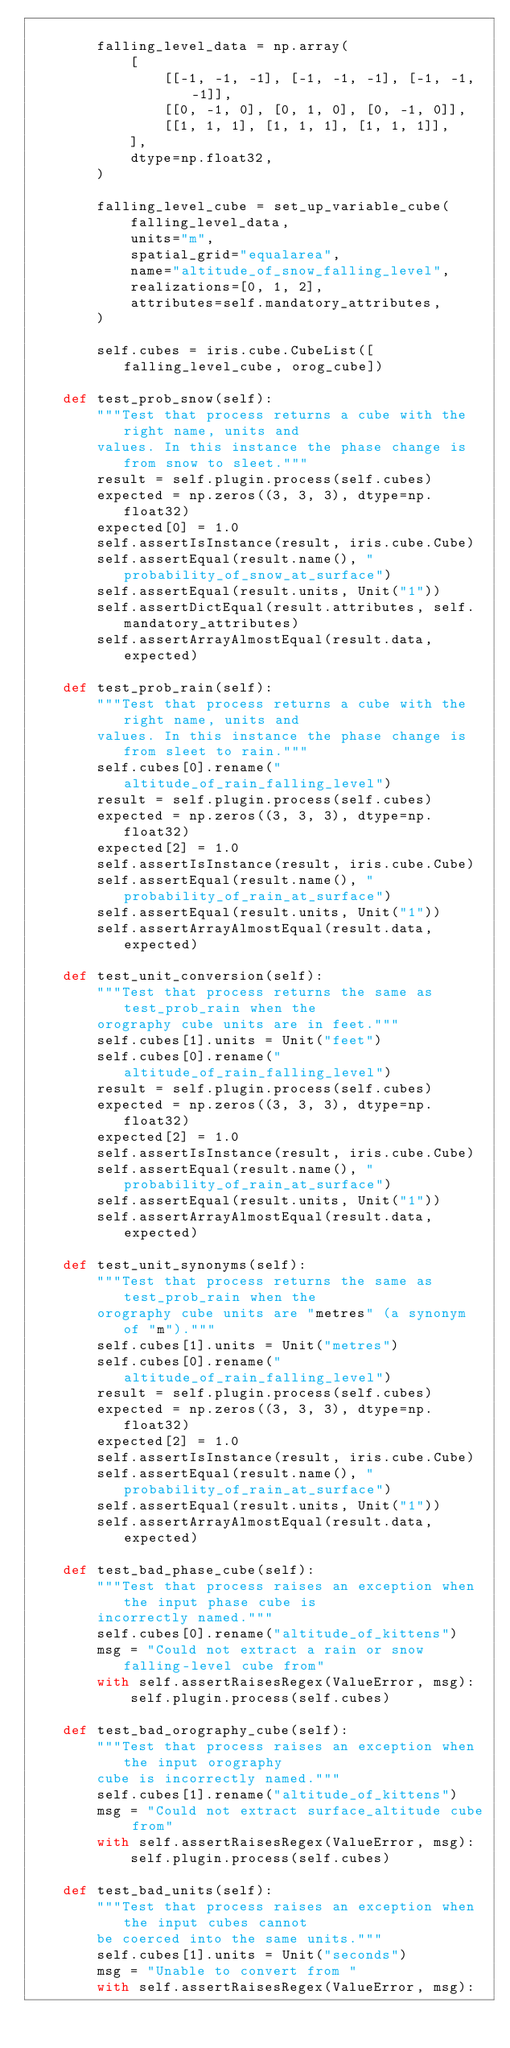<code> <loc_0><loc_0><loc_500><loc_500><_Python_>
        falling_level_data = np.array(
            [
                [[-1, -1, -1], [-1, -1, -1], [-1, -1, -1]],
                [[0, -1, 0], [0, 1, 0], [0, -1, 0]],
                [[1, 1, 1], [1, 1, 1], [1, 1, 1]],
            ],
            dtype=np.float32,
        )

        falling_level_cube = set_up_variable_cube(
            falling_level_data,
            units="m",
            spatial_grid="equalarea",
            name="altitude_of_snow_falling_level",
            realizations=[0, 1, 2],
            attributes=self.mandatory_attributes,
        )

        self.cubes = iris.cube.CubeList([falling_level_cube, orog_cube])

    def test_prob_snow(self):
        """Test that process returns a cube with the right name, units and
        values. In this instance the phase change is from snow to sleet."""
        result = self.plugin.process(self.cubes)
        expected = np.zeros((3, 3, 3), dtype=np.float32)
        expected[0] = 1.0
        self.assertIsInstance(result, iris.cube.Cube)
        self.assertEqual(result.name(), "probability_of_snow_at_surface")
        self.assertEqual(result.units, Unit("1"))
        self.assertDictEqual(result.attributes, self.mandatory_attributes)
        self.assertArrayAlmostEqual(result.data, expected)

    def test_prob_rain(self):
        """Test that process returns a cube with the right name, units and
        values. In this instance the phase change is from sleet to rain."""
        self.cubes[0].rename("altitude_of_rain_falling_level")
        result = self.plugin.process(self.cubes)
        expected = np.zeros((3, 3, 3), dtype=np.float32)
        expected[2] = 1.0
        self.assertIsInstance(result, iris.cube.Cube)
        self.assertEqual(result.name(), "probability_of_rain_at_surface")
        self.assertEqual(result.units, Unit("1"))
        self.assertArrayAlmostEqual(result.data, expected)

    def test_unit_conversion(self):
        """Test that process returns the same as test_prob_rain when the
        orography cube units are in feet."""
        self.cubes[1].units = Unit("feet")
        self.cubes[0].rename("altitude_of_rain_falling_level")
        result = self.plugin.process(self.cubes)
        expected = np.zeros((3, 3, 3), dtype=np.float32)
        expected[2] = 1.0
        self.assertIsInstance(result, iris.cube.Cube)
        self.assertEqual(result.name(), "probability_of_rain_at_surface")
        self.assertEqual(result.units, Unit("1"))
        self.assertArrayAlmostEqual(result.data, expected)

    def test_unit_synonyms(self):
        """Test that process returns the same as test_prob_rain when the
        orography cube units are "metres" (a synonym of "m")."""
        self.cubes[1].units = Unit("metres")
        self.cubes[0].rename("altitude_of_rain_falling_level")
        result = self.plugin.process(self.cubes)
        expected = np.zeros((3, 3, 3), dtype=np.float32)
        expected[2] = 1.0
        self.assertIsInstance(result, iris.cube.Cube)
        self.assertEqual(result.name(), "probability_of_rain_at_surface")
        self.assertEqual(result.units, Unit("1"))
        self.assertArrayAlmostEqual(result.data, expected)

    def test_bad_phase_cube(self):
        """Test that process raises an exception when the input phase cube is
        incorrectly named."""
        self.cubes[0].rename("altitude_of_kittens")
        msg = "Could not extract a rain or snow falling-level cube from"
        with self.assertRaisesRegex(ValueError, msg):
            self.plugin.process(self.cubes)

    def test_bad_orography_cube(self):
        """Test that process raises an exception when the input orography
        cube is incorrectly named."""
        self.cubes[1].rename("altitude_of_kittens")
        msg = "Could not extract surface_altitude cube from"
        with self.assertRaisesRegex(ValueError, msg):
            self.plugin.process(self.cubes)

    def test_bad_units(self):
        """Test that process raises an exception when the input cubes cannot
        be coerced into the same units."""
        self.cubes[1].units = Unit("seconds")
        msg = "Unable to convert from "
        with self.assertRaisesRegex(ValueError, msg):</code> 